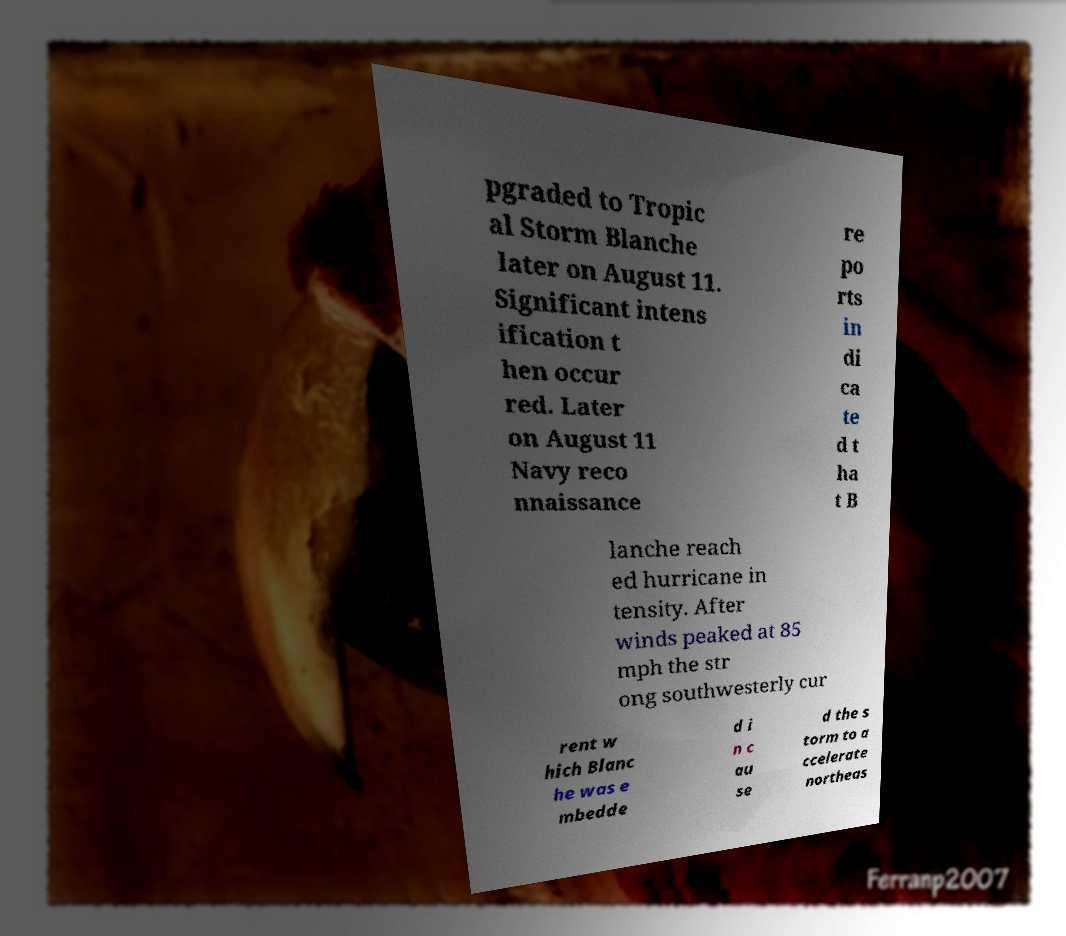Could you extract and type out the text from this image? pgraded to Tropic al Storm Blanche later on August 11. Significant intens ification t hen occur red. Later on August 11 Navy reco nnaissance re po rts in di ca te d t ha t B lanche reach ed hurricane in tensity. After winds peaked at 85 mph the str ong southwesterly cur rent w hich Blanc he was e mbedde d i n c au se d the s torm to a ccelerate northeas 